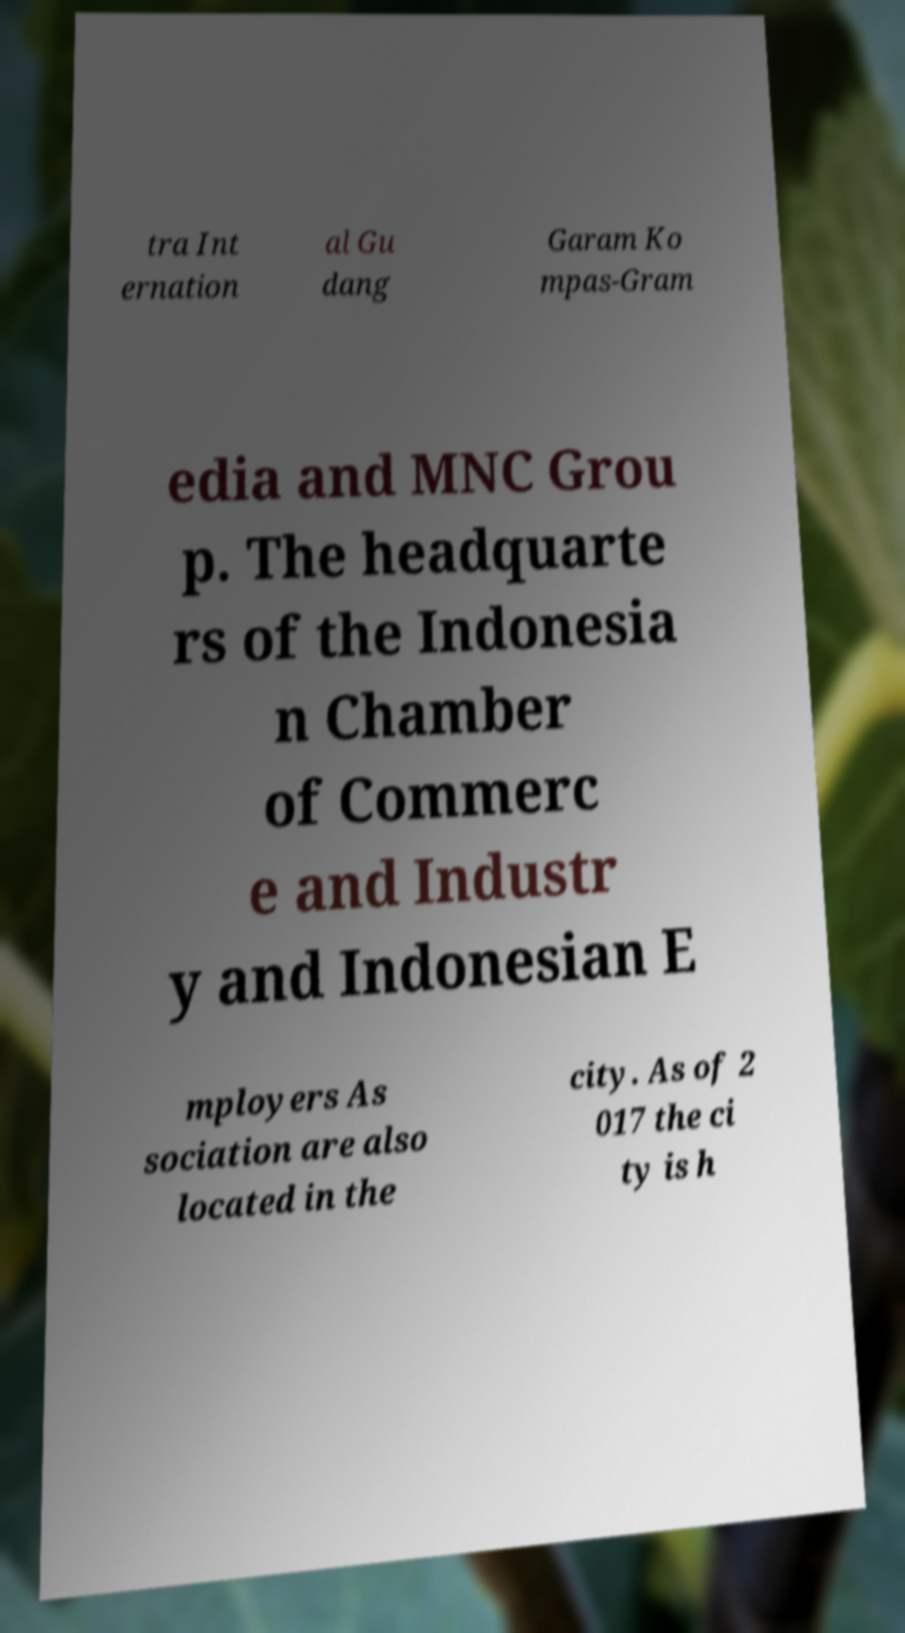I need the written content from this picture converted into text. Can you do that? tra Int ernation al Gu dang Garam Ko mpas-Gram edia and MNC Grou p. The headquarte rs of the Indonesia n Chamber of Commerc e and Industr y and Indonesian E mployers As sociation are also located in the city. As of 2 017 the ci ty is h 